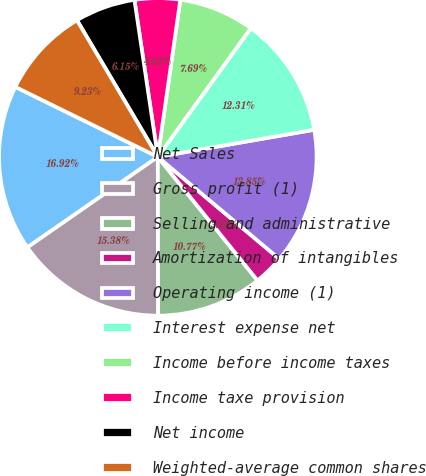Convert chart to OTSL. <chart><loc_0><loc_0><loc_500><loc_500><pie_chart><fcel>Net Sales<fcel>Gross profit (1)<fcel>Selling and administrative<fcel>Amortization of intangibles<fcel>Operating income (1)<fcel>Interest expense net<fcel>Income before income taxes<fcel>Income taxe provision<fcel>Net income<fcel>Weighted-average common shares<nl><fcel>16.92%<fcel>15.38%<fcel>10.77%<fcel>3.08%<fcel>13.85%<fcel>12.31%<fcel>7.69%<fcel>4.62%<fcel>6.15%<fcel>9.23%<nl></chart> 